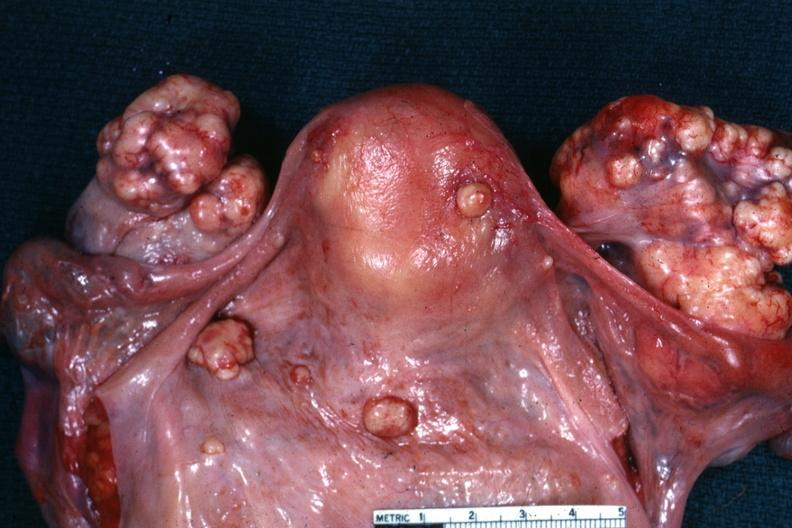what was in the stomach this is true bilateral krukenberg?
Answer the question using a single word or phrase. Peritoneal surface of uterus and douglas pouch outstanding photo primary 